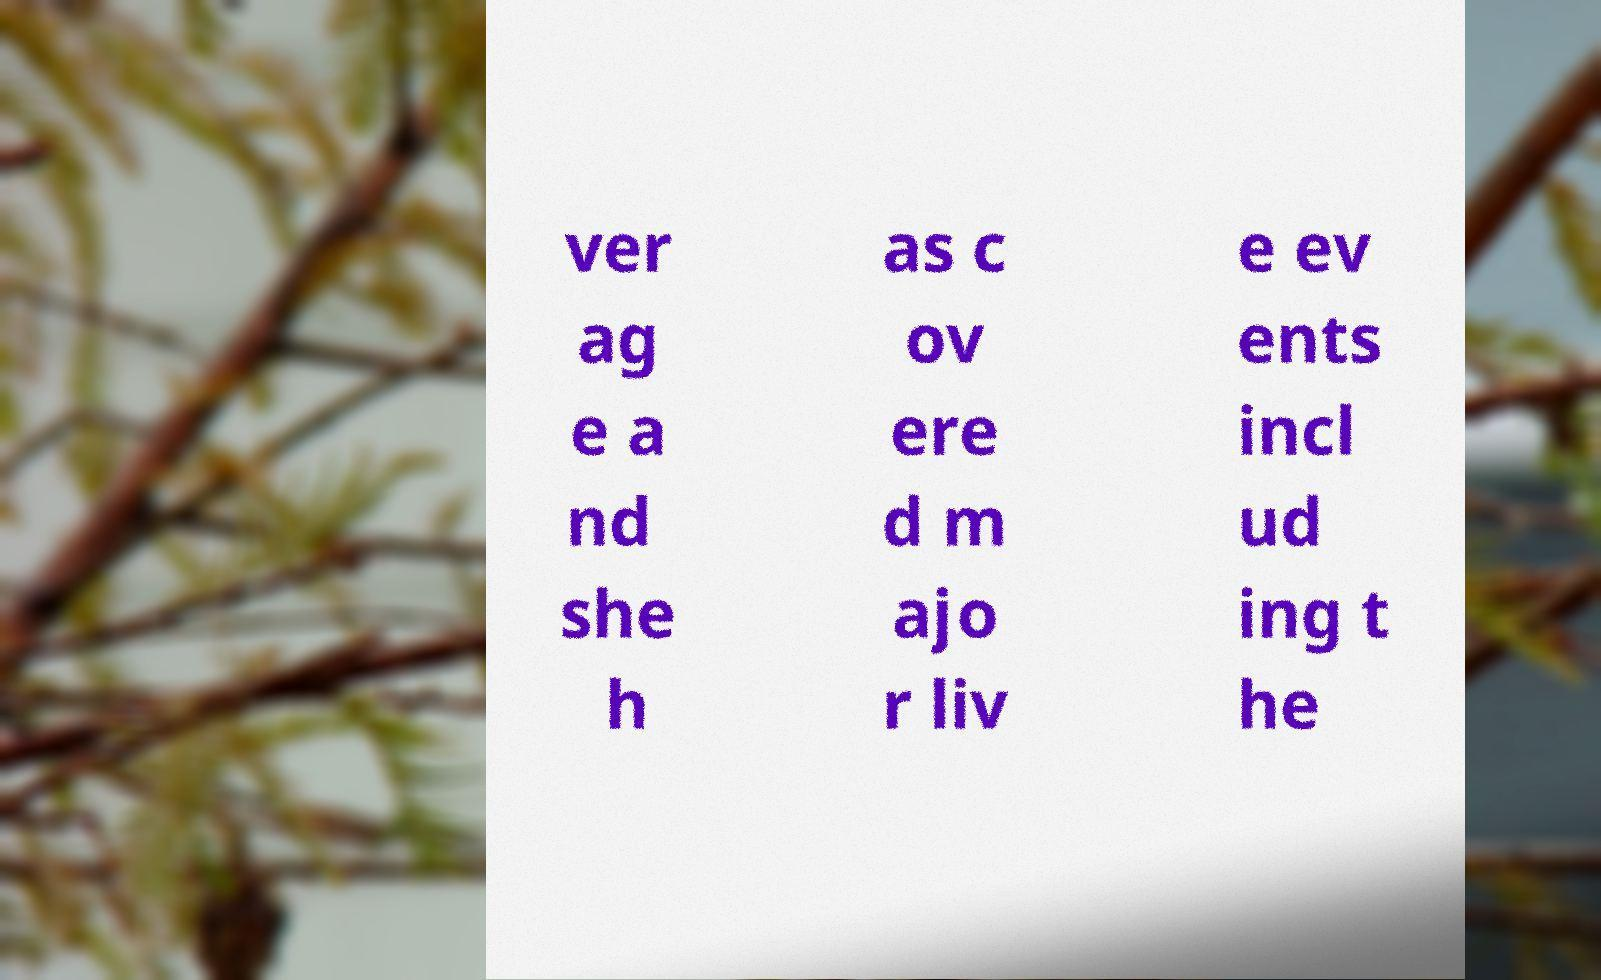Please read and relay the text visible in this image. What does it say? ver ag e a nd she h as c ov ere d m ajo r liv e ev ents incl ud ing t he 